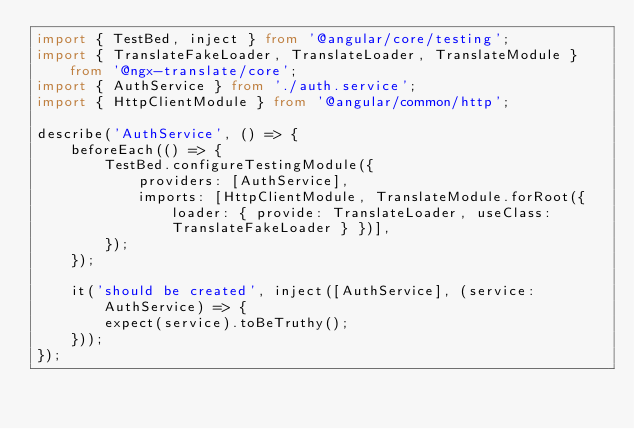Convert code to text. <code><loc_0><loc_0><loc_500><loc_500><_TypeScript_>import { TestBed, inject } from '@angular/core/testing';
import { TranslateFakeLoader, TranslateLoader, TranslateModule } from '@ngx-translate/core';
import { AuthService } from './auth.service';
import { HttpClientModule } from '@angular/common/http';

describe('AuthService', () => {
    beforeEach(() => {
        TestBed.configureTestingModule({
            providers: [AuthService],
            imports: [HttpClientModule, TranslateModule.forRoot({ loader: { provide: TranslateLoader, useClass: TranslateFakeLoader } })],
        });
    });

    it('should be created', inject([AuthService], (service: AuthService) => {
        expect(service).toBeTruthy();
    }));
});
</code> 